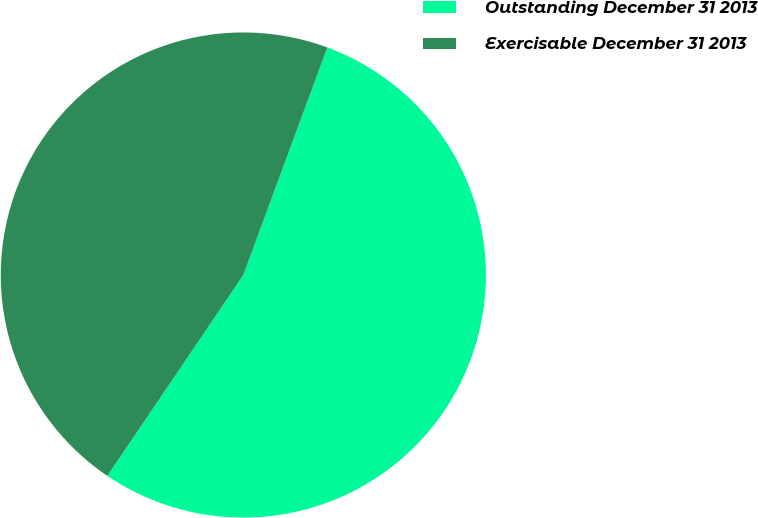Convert chart. <chart><loc_0><loc_0><loc_500><loc_500><pie_chart><fcel>Outstanding December 31 2013<fcel>Exercisable December 31 2013<nl><fcel>53.84%<fcel>46.16%<nl></chart> 